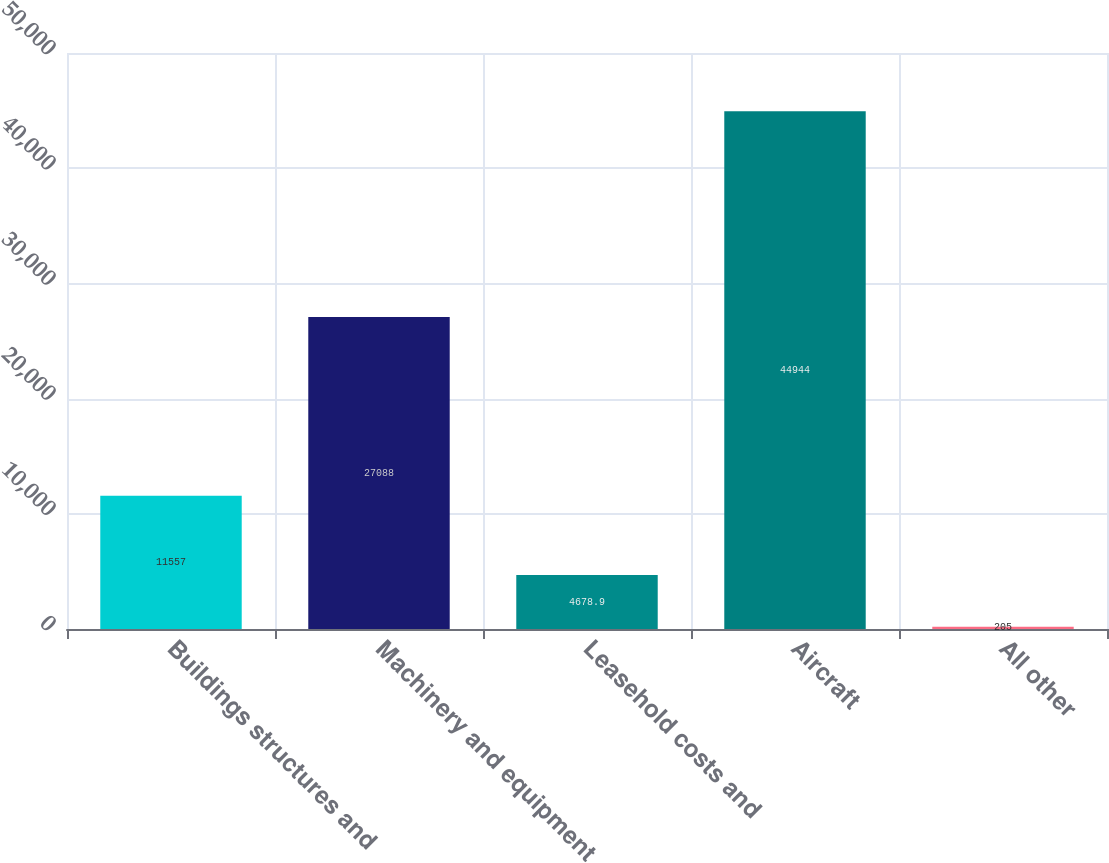Convert chart to OTSL. <chart><loc_0><loc_0><loc_500><loc_500><bar_chart><fcel>Buildings structures and<fcel>Machinery and equipment<fcel>Leasehold costs and<fcel>Aircraft<fcel>All other<nl><fcel>11557<fcel>27088<fcel>4678.9<fcel>44944<fcel>205<nl></chart> 